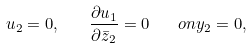Convert formula to latex. <formula><loc_0><loc_0><loc_500><loc_500>u _ { 2 } = 0 , \quad \frac { \partial u _ { 1 } } { \partial \bar { z } _ { 2 } } = 0 \quad o n y _ { 2 } = 0 ,</formula> 